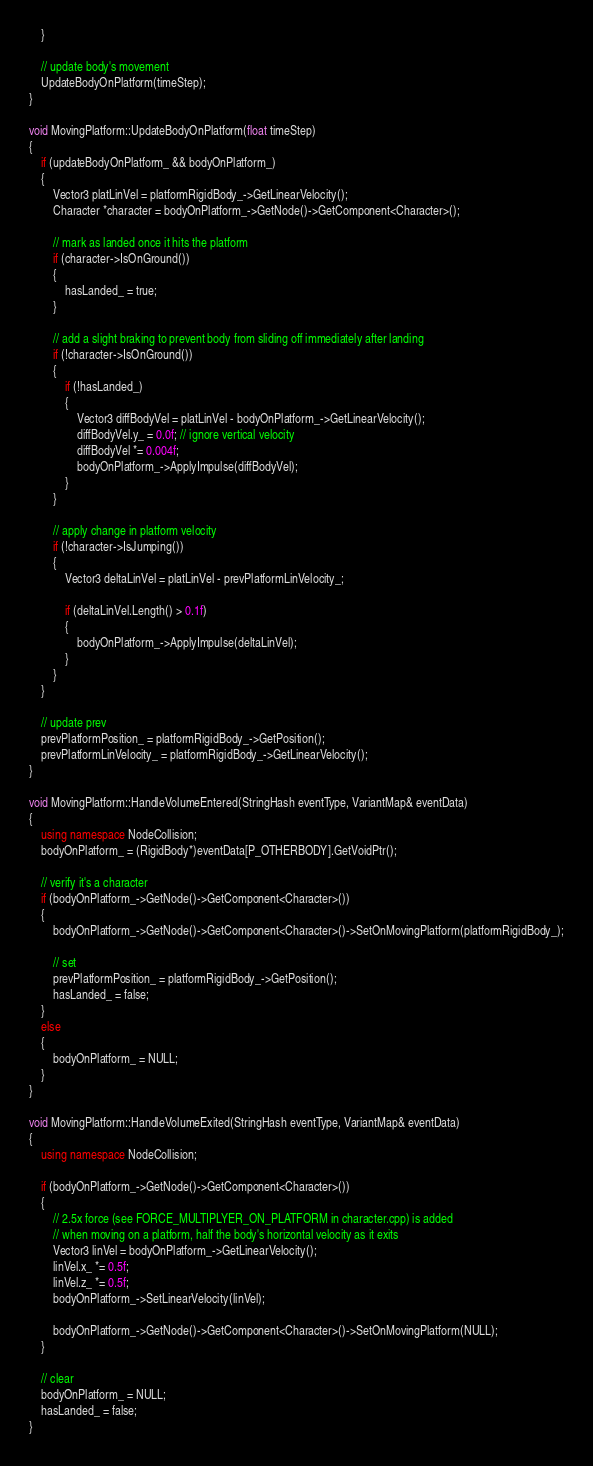<code> <loc_0><loc_0><loc_500><loc_500><_C++_>    }

    // update body's movement
    UpdateBodyOnPlatform(timeStep);
}

void MovingPlatform::UpdateBodyOnPlatform(float timeStep)
{
    if (updateBodyOnPlatform_ && bodyOnPlatform_)
    {
        Vector3 platLinVel = platformRigidBody_->GetLinearVelocity();
        Character *character = bodyOnPlatform_->GetNode()->GetComponent<Character>();

        // mark as landed once it hits the platform
        if (character->IsOnGround())
        {
            hasLanded_ = true;
        }

        // add a slight braking to prevent body from sliding off immediately after landing
        if (!character->IsOnGround())
        {
            if (!hasLanded_)
            {
                Vector3 diffBodyVel = platLinVel - bodyOnPlatform_->GetLinearVelocity();
                diffBodyVel.y_ = 0.0f; // ignore vertical velocity
                diffBodyVel *= 0.004f;
                bodyOnPlatform_->ApplyImpulse(diffBodyVel);
            }
        }

        // apply change in platform velocity
        if (!character->IsJumping())
        {
            Vector3 deltaLinVel = platLinVel - prevPlatformLinVelocity_;

            if (deltaLinVel.Length() > 0.1f)
            {
                bodyOnPlatform_->ApplyImpulse(deltaLinVel);
            }
        }
    }

    // update prev
    prevPlatformPosition_ = platformRigidBody_->GetPosition();
    prevPlatformLinVelocity_ = platformRigidBody_->GetLinearVelocity();
}

void MovingPlatform::HandleVolumeEntered(StringHash eventType, VariantMap& eventData)
{
    using namespace NodeCollision;
    bodyOnPlatform_ = (RigidBody*)eventData[P_OTHERBODY].GetVoidPtr();

    // verify it's a character
    if (bodyOnPlatform_->GetNode()->GetComponent<Character>())
    {
        bodyOnPlatform_->GetNode()->GetComponent<Character>()->SetOnMovingPlatform(platformRigidBody_);

        // set
        prevPlatformPosition_ = platformRigidBody_->GetPosition();
        hasLanded_ = false;
    }
    else
    {
        bodyOnPlatform_ = NULL;
    }
}

void MovingPlatform::HandleVolumeExited(StringHash eventType, VariantMap& eventData)
{
    using namespace NodeCollision;

    if (bodyOnPlatform_->GetNode()->GetComponent<Character>())
    {
        // 2.5x force (see FORCE_MULTIPLYER_ON_PLATFORM in character.cpp) is added 
        // when moving on a platform, half the body's horizontal velocity as it exits
        Vector3 linVel = bodyOnPlatform_->GetLinearVelocity();
        linVel.x_ *= 0.5f;
        linVel.z_ *= 0.5f;
        bodyOnPlatform_->SetLinearVelocity(linVel);

        bodyOnPlatform_->GetNode()->GetComponent<Character>()->SetOnMovingPlatform(NULL);
    }

    // clear
    bodyOnPlatform_ = NULL;
    hasLanded_ = false;
}



</code> 